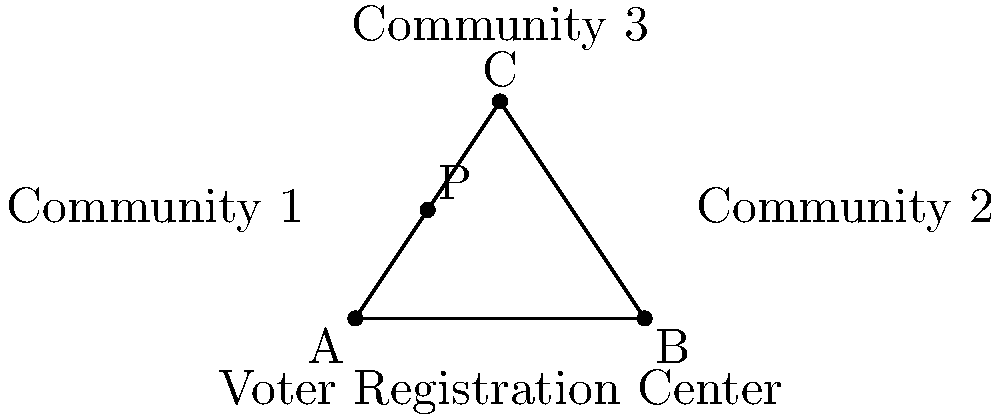As a civil rights leader organizing voter registration drives, you need to determine the optimal location for a central registration center to serve three communities. The coordinates of the communities are A(0,0), B(8,0), and C(4,6). A potential location P(2,3) has been suggested. Using the distance formula, calculate the sum of the distances from point P to each community. Then, determine if moving the center to the centroid of the triangle formed by the three communities would reduce the total distance. The centroid is located at $(\frac{x_A + x_B + x_C}{3}, \frac{y_A + y_B + y_C}{3})$. Which location would you recommend for the voter registration center? Step 1: Calculate the distances from P to each community using the distance formula $d = \sqrt{(x_2-x_1)^2 + (y_2-y_1)^2}$

PA = $\sqrt{(2-0)^2 + (3-0)^2} = \sqrt{4 + 9} = \sqrt{13} \approx 3.61$
PB = $\sqrt{(2-8)^2 + (3-0)^2} = \sqrt{36 + 9} = \sqrt{45} = 3\sqrt{5} \approx 6.71$
PC = $\sqrt{(2-4)^2 + (3-6)^2} = \sqrt{4 + 9} = \sqrt{13} \approx 3.61$

Step 2: Sum the distances
Total distance for P = PA + PB + PC ≈ 3.61 + 6.71 + 3.61 = 13.93

Step 3: Calculate the centroid coordinates
$x_{centroid} = \frac{0 + 8 + 4}{3} = 4$
$y_{centroid} = \frac{0 + 0 + 6}{3} = 2$
Centroid = (4,2)

Step 4: Calculate distances from the centroid to each community
CA = $\sqrt{(4-0)^2 + (2-0)^2} = \sqrt{16 + 4} = \sqrt{20} = 2\sqrt{5} \approx 4.47$
CB = $\sqrt{(4-8)^2 + (2-0)^2} = \sqrt{16 + 4} = \sqrt{20} = 2\sqrt{5} \approx 4.47$
CC = $\sqrt{(4-4)^2 + (2-6)^2} = \sqrt{0 + 16} = 4$

Step 5: Sum the distances for the centroid
Total distance for centroid = CA + CB + CC ≈ 4.47 + 4.47 + 4 = 12.94

Step 6: Compare the total distances
The centroid (12.94) has a smaller total distance than point P (13.93).

Therefore, the centroid location (4,2) would be the recommended location for the voter registration center as it minimizes the total distance traveled by all communities.
Answer: Centroid (4,2) 